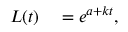Convert formula to latex. <formula><loc_0><loc_0><loc_500><loc_500>\begin{array} { r l } { L ( t ) } & = e ^ { a + k t } , } \end{array}</formula> 